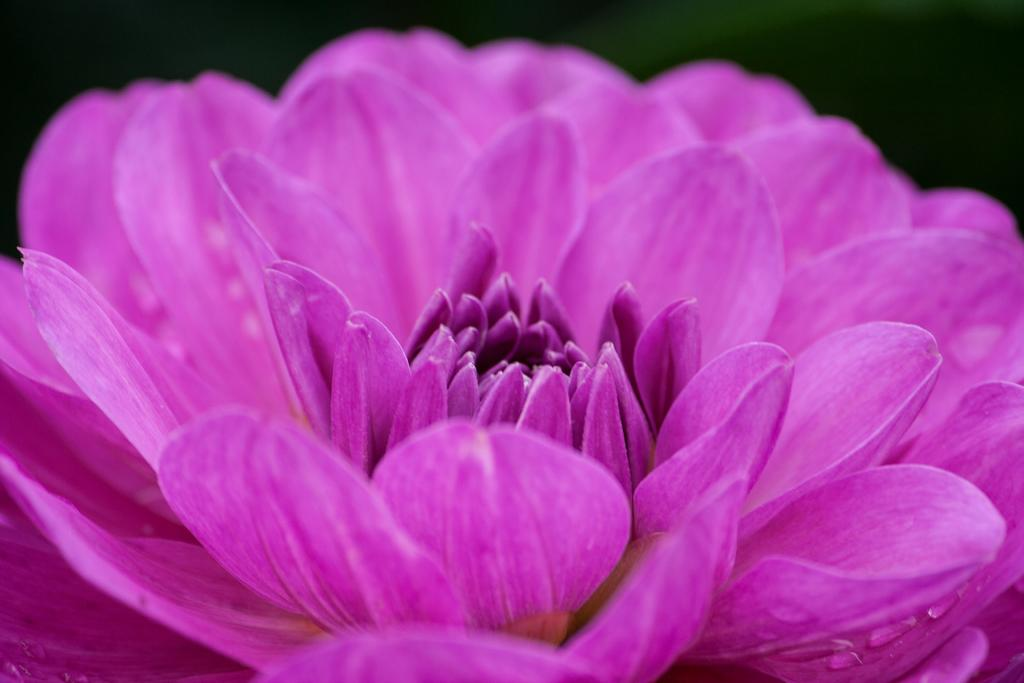What is the main subject of the image? There is a flower in the image. Can you describe the flower's appearance? The flower has water drops on it. What type of humor can be seen in the image? There is no humor present in the image; it features a flower with water drops on it. Can you tell me how many leaves are on the flower in the image? The image only shows a flower with water drops on it, and there is no mention of leaves. 